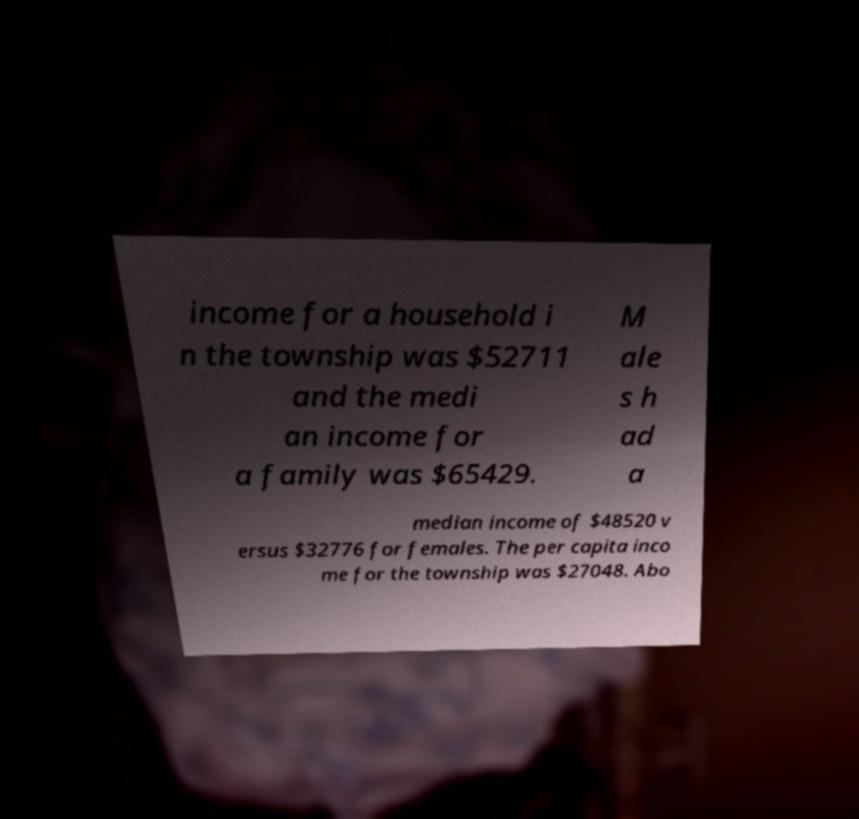Could you extract and type out the text from this image? income for a household i n the township was $52711 and the medi an income for a family was $65429. M ale s h ad a median income of $48520 v ersus $32776 for females. The per capita inco me for the township was $27048. Abo 